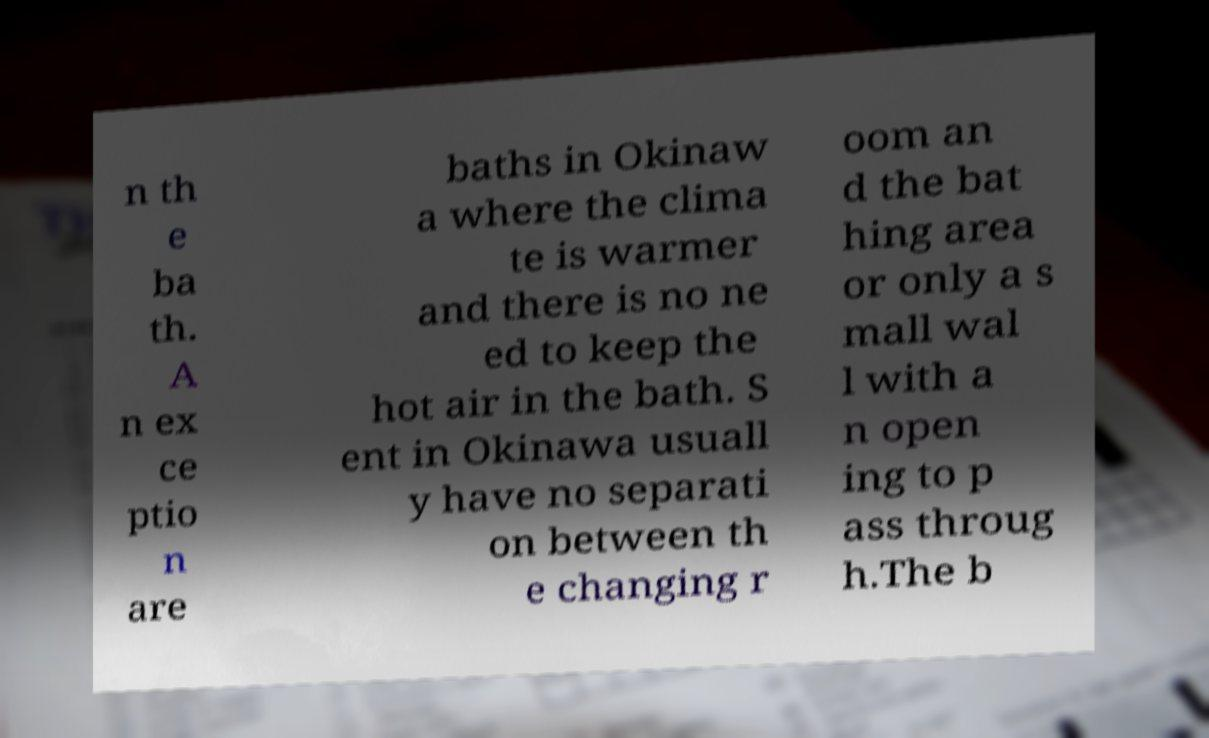Can you accurately transcribe the text from the provided image for me? n th e ba th. A n ex ce ptio n are baths in Okinaw a where the clima te is warmer and there is no ne ed to keep the hot air in the bath. S ent in Okinawa usuall y have no separati on between th e changing r oom an d the bat hing area or only a s mall wal l with a n open ing to p ass throug h.The b 